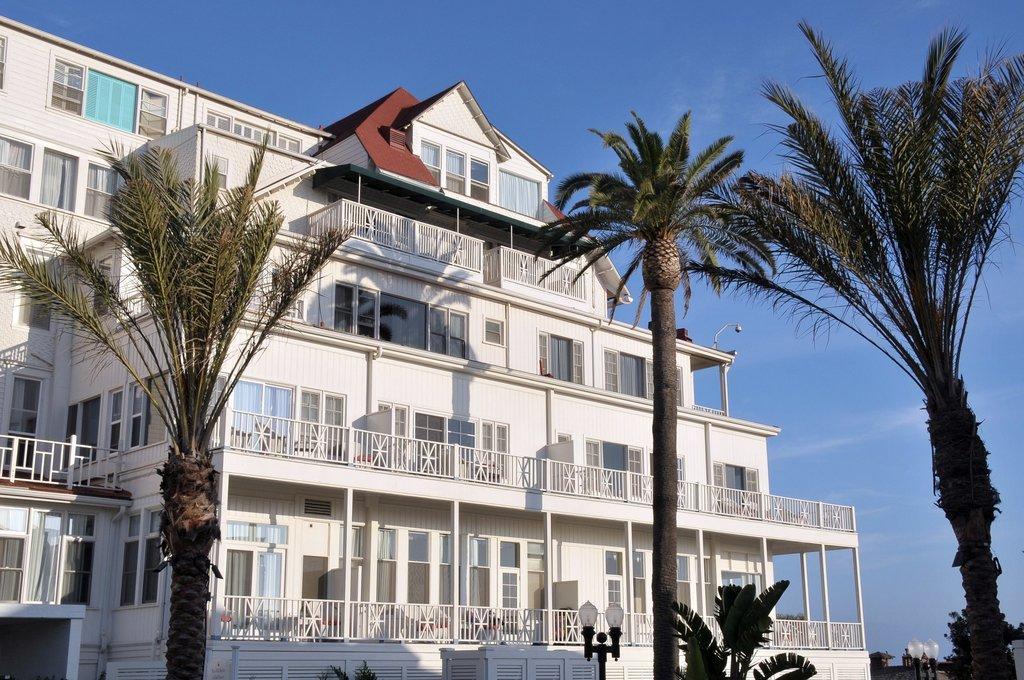In one or two sentences, can you explain what this image depicts? In this image we can see a building, lights, and trees. In the background there is sky. 